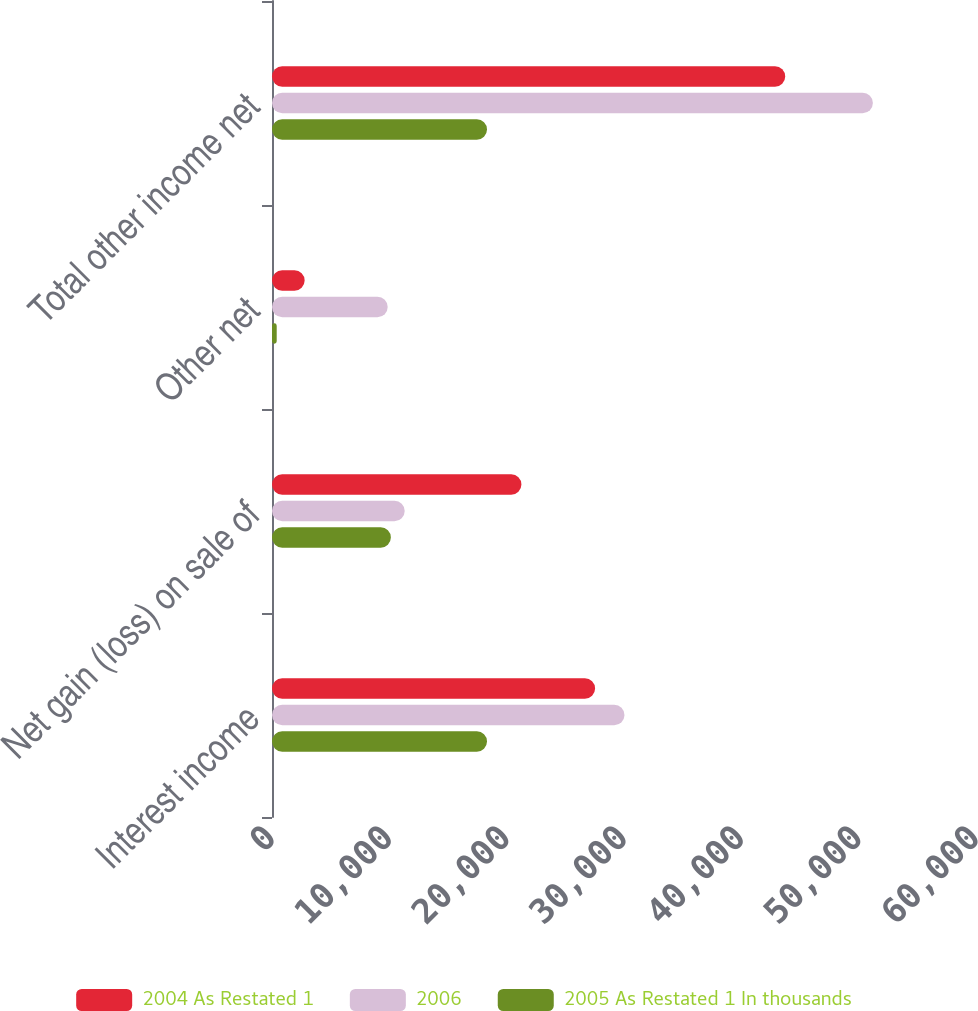Convert chart to OTSL. <chart><loc_0><loc_0><loc_500><loc_500><stacked_bar_chart><ecel><fcel>Interest income<fcel>Net gain (loss) on sale of<fcel>Other net<fcel>Total other income net<nl><fcel>2004 As Restated 1<fcel>27537<fcel>21258<fcel>2783<fcel>43740<nl><fcel>2006<fcel>30041<fcel>11310<fcel>9860<fcel>51211<nl><fcel>2005 As Restated 1 In thousands<fcel>18325<fcel>10131<fcel>401<fcel>18325<nl></chart> 